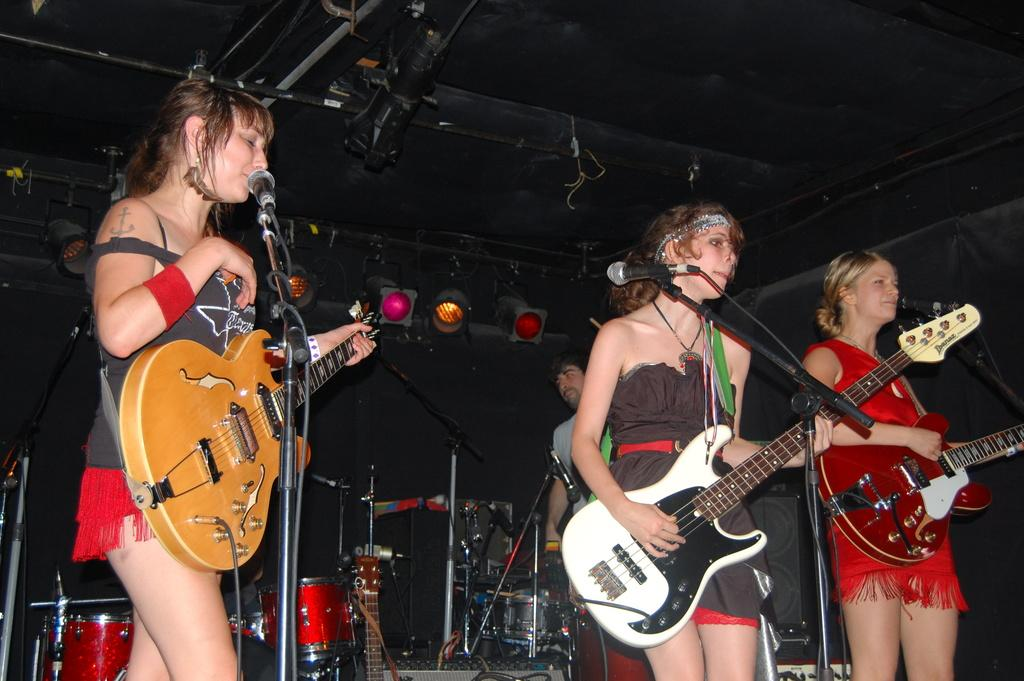How many girls are in the image? There are three girls in the image. What are the girls doing in the image? The girls are standing on a stage and playing guitar. Who else is on the stage with the girls? There is a man on the stage with the girls. What is the man doing in the image? The man is standing on the stage and playing drums. What type of coat is the slave wearing in the image? There is no slave or coat present in the image. 